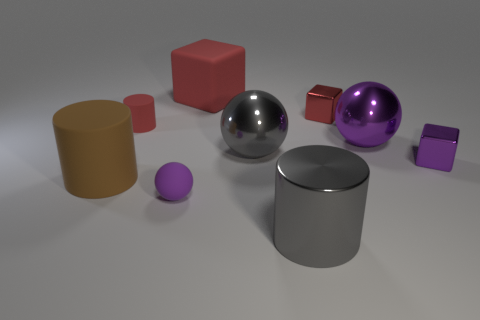Subtract all small cubes. How many cubes are left? 1 Subtract all cylinders. How many objects are left? 6 Subtract all gray spheres. How many spheres are left? 2 Add 1 tiny purple blocks. How many objects exist? 10 Add 5 gray spheres. How many gray spheres are left? 6 Add 4 small red cubes. How many small red cubes exist? 5 Subtract 1 red cylinders. How many objects are left? 8 Subtract 2 spheres. How many spheres are left? 1 Subtract all purple blocks. Subtract all red cylinders. How many blocks are left? 2 Subtract all brown cylinders. How many cyan spheres are left? 0 